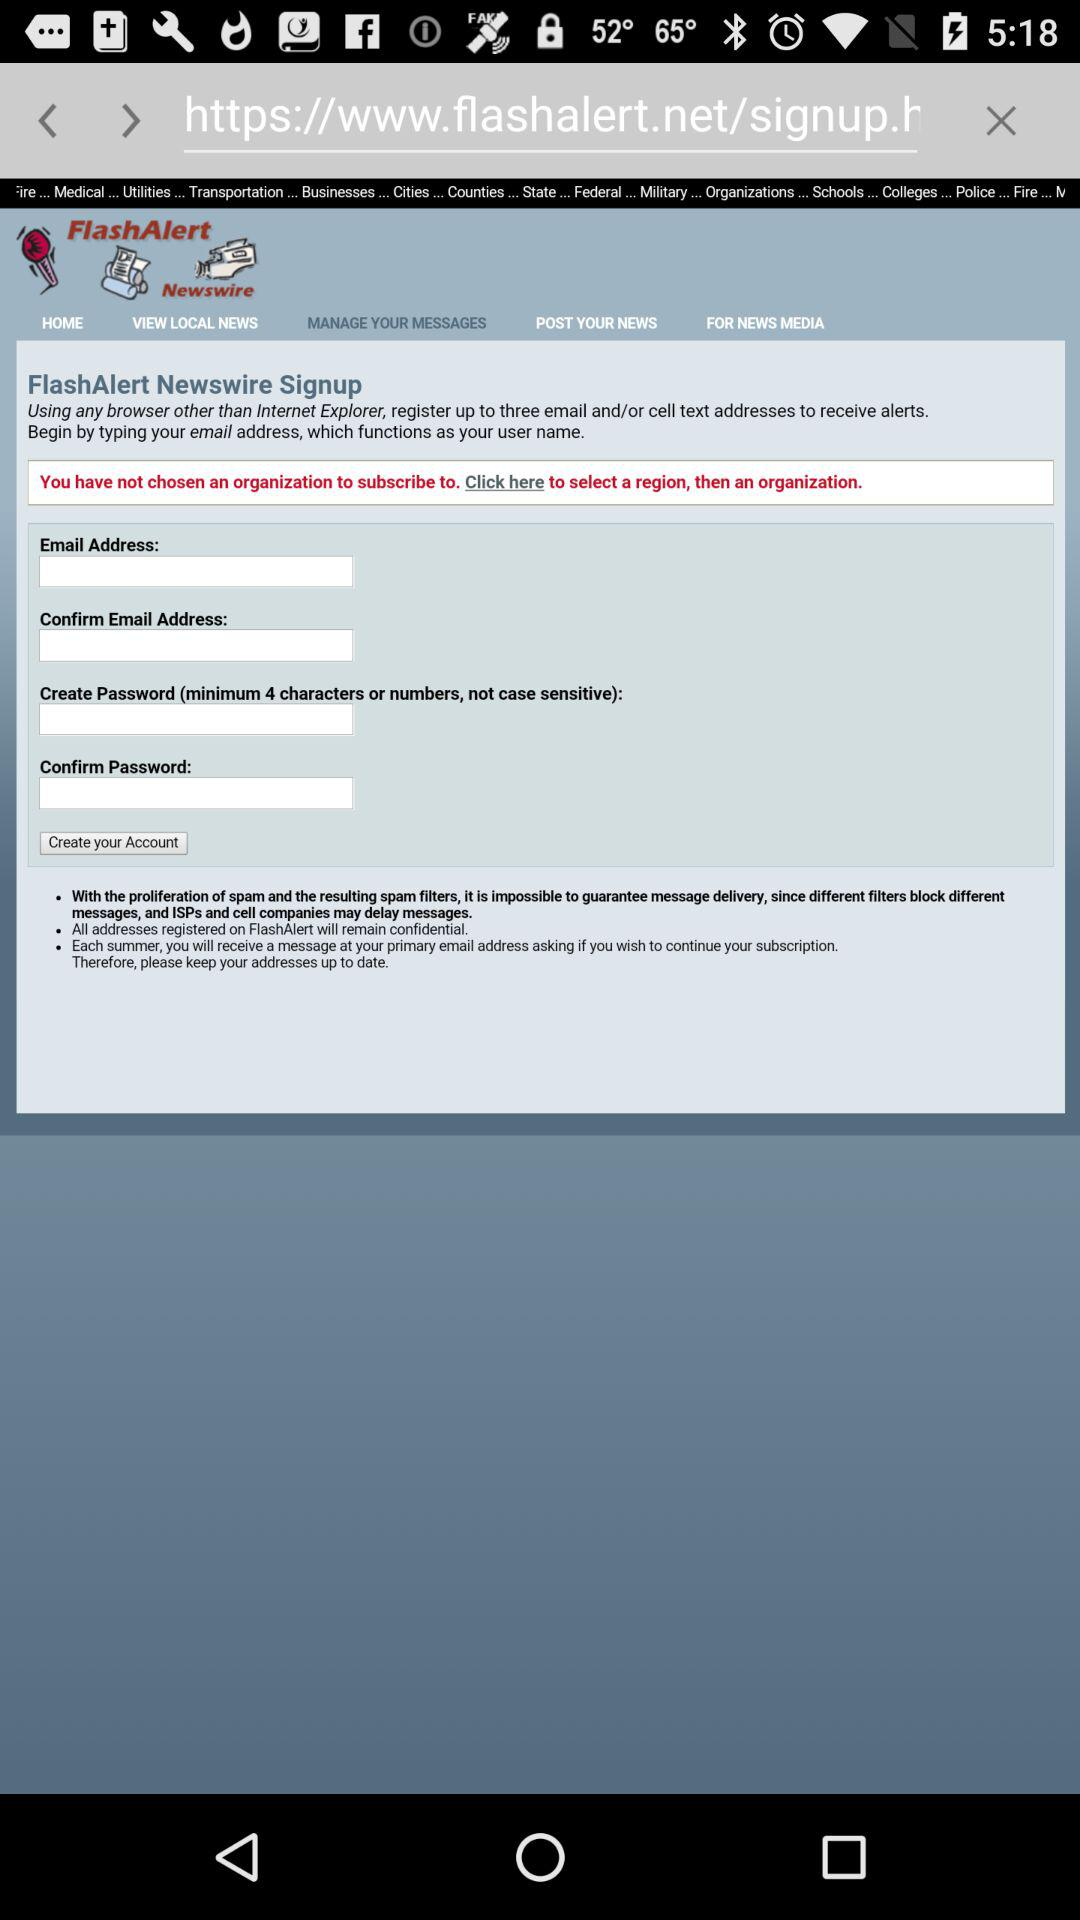What is the name of the application? The name of the application is "FlashAlert". 